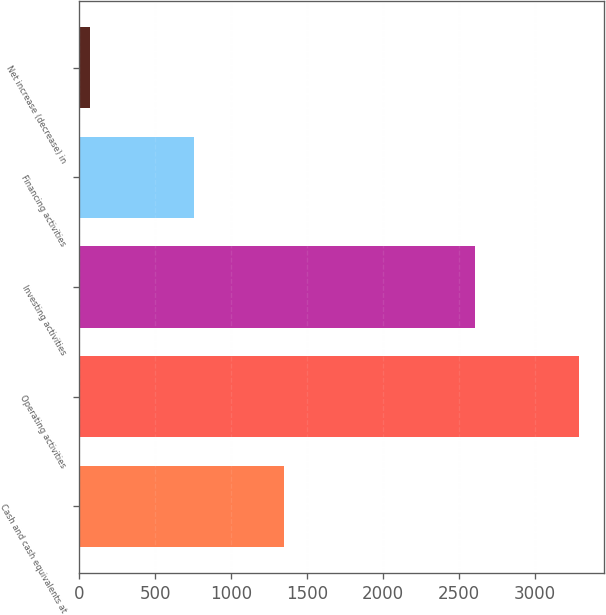Convert chart. <chart><loc_0><loc_0><loc_500><loc_500><bar_chart><fcel>Cash and cash equivalents at<fcel>Operating activities<fcel>Investing activities<fcel>Financing activities<fcel>Net increase (decrease) in<nl><fcel>1351<fcel>3291<fcel>2609<fcel>753<fcel>71<nl></chart> 